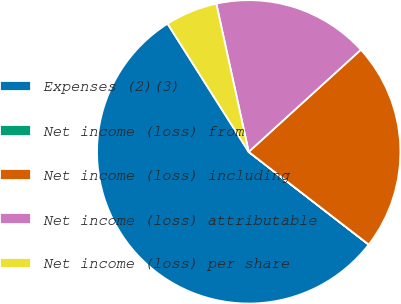Convert chart. <chart><loc_0><loc_0><loc_500><loc_500><pie_chart><fcel>Expenses (2)(3)<fcel>Net income (loss) from<fcel>Net income (loss) including<fcel>Net income (loss) attributable<fcel>Net income (loss) per share<nl><fcel>55.54%<fcel>0.01%<fcel>22.22%<fcel>16.67%<fcel>5.56%<nl></chart> 